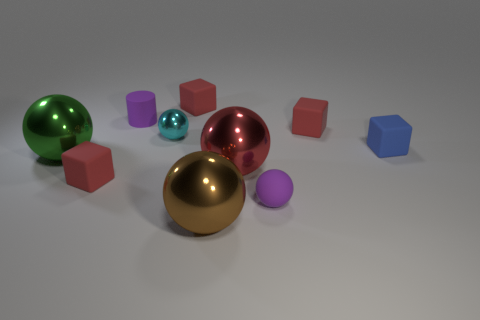What number of purple cylinders have the same size as the purple matte ball?
Ensure brevity in your answer.  1. Are the tiny red block that is on the right side of the brown sphere and the green object made of the same material?
Provide a succinct answer. No. Are any brown metallic objects visible?
Offer a terse response. Yes. What is the size of the green object that is the same material as the big red ball?
Give a very brief answer. Large. Is there a matte cylinder of the same color as the matte sphere?
Give a very brief answer. Yes. Do the tiny rubber block on the left side of the small shiny sphere and the metal object on the right side of the brown metallic ball have the same color?
Your answer should be very brief. Yes. Are there any large green things that have the same material as the brown sphere?
Your response must be concise. Yes. The small shiny sphere has what color?
Ensure brevity in your answer.  Cyan. How big is the metallic thing that is in front of the small red object in front of the tiny red matte cube on the right side of the purple sphere?
Your response must be concise. Large. How many other things are there of the same shape as the brown object?
Offer a very short reply. 4. 